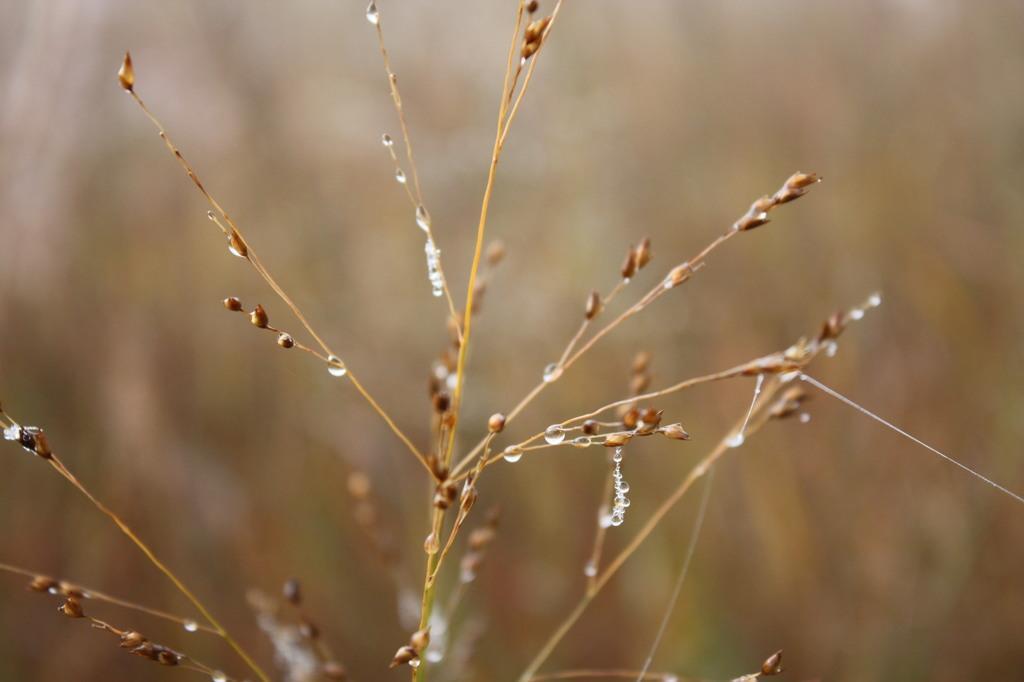In one or two sentences, can you explain what this image depicts? In this image there are few water drops on the dry grass. 